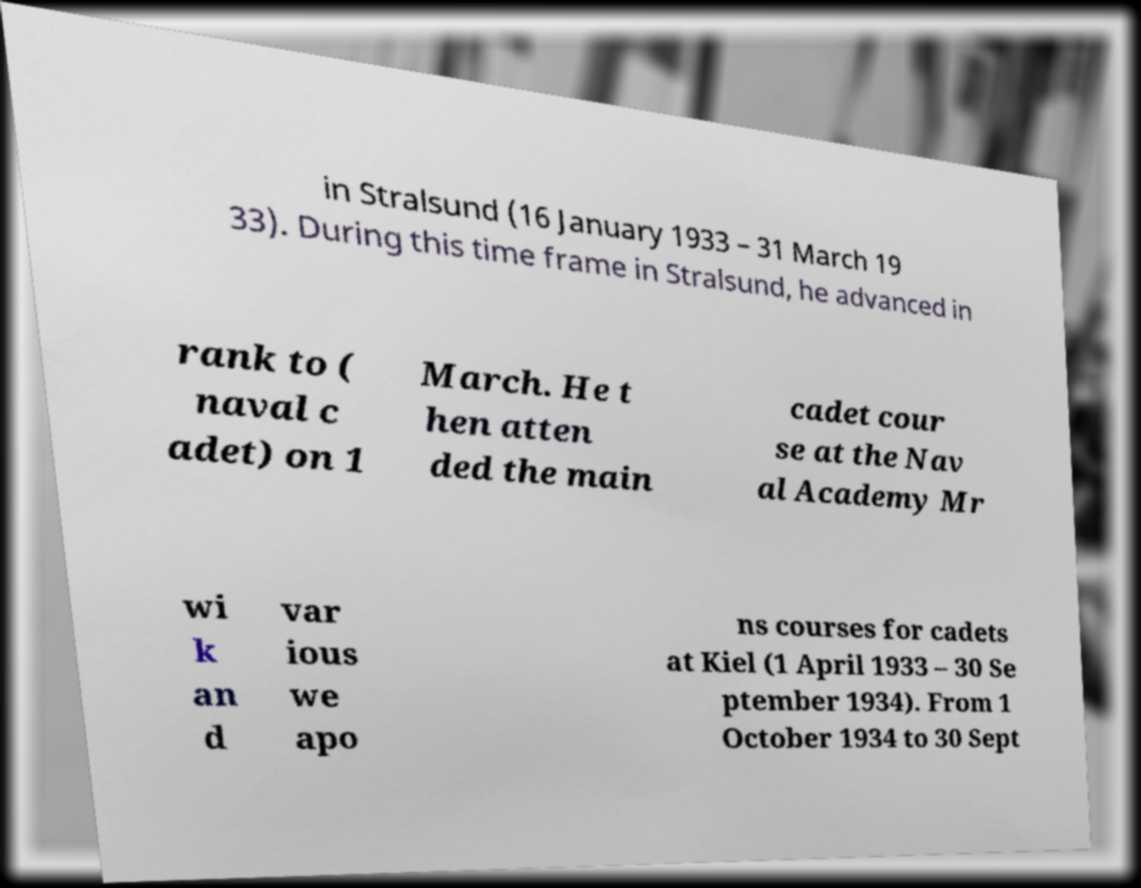For documentation purposes, I need the text within this image transcribed. Could you provide that? in Stralsund (16 January 1933 – 31 March 19 33). During this time frame in Stralsund, he advanced in rank to ( naval c adet) on 1 March. He t hen atten ded the main cadet cour se at the Nav al Academy Mr wi k an d var ious we apo ns courses for cadets at Kiel (1 April 1933 – 30 Se ptember 1934). From 1 October 1934 to 30 Sept 